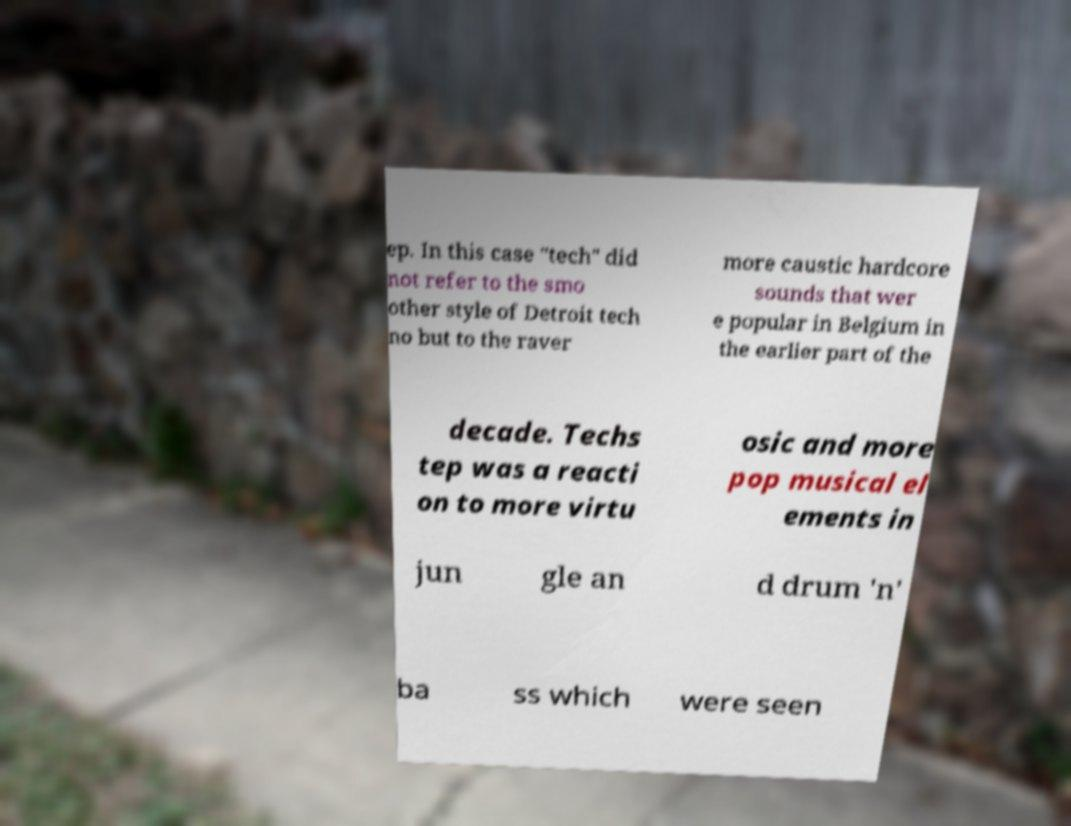Could you extract and type out the text from this image? ep. In this case "tech" did not refer to the smo other style of Detroit tech no but to the raver more caustic hardcore sounds that wer e popular in Belgium in the earlier part of the decade. Techs tep was a reacti on to more virtu osic and more pop musical el ements in jun gle an d drum 'n' ba ss which were seen 